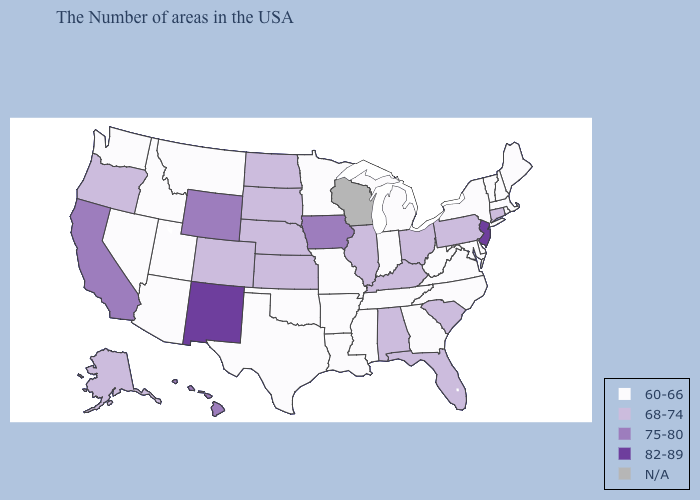What is the value of Wisconsin?
Quick response, please. N/A. What is the highest value in the MidWest ?
Short answer required. 75-80. What is the value of South Dakota?
Give a very brief answer. 68-74. Name the states that have a value in the range N/A?
Concise answer only. Wisconsin. Name the states that have a value in the range 60-66?
Quick response, please. Maine, Massachusetts, Rhode Island, New Hampshire, Vermont, New York, Delaware, Maryland, Virginia, North Carolina, West Virginia, Georgia, Michigan, Indiana, Tennessee, Mississippi, Louisiana, Missouri, Arkansas, Minnesota, Oklahoma, Texas, Utah, Montana, Arizona, Idaho, Nevada, Washington. Does the map have missing data?
Give a very brief answer. Yes. What is the value of Georgia?
Keep it brief. 60-66. What is the highest value in states that border Iowa?
Answer briefly. 68-74. Name the states that have a value in the range 82-89?
Short answer required. New Jersey, New Mexico. Name the states that have a value in the range N/A?
Answer briefly. Wisconsin. What is the value of Nebraska?
Give a very brief answer. 68-74. What is the value of Nebraska?
Be succinct. 68-74. What is the value of Tennessee?
Quick response, please. 60-66. 